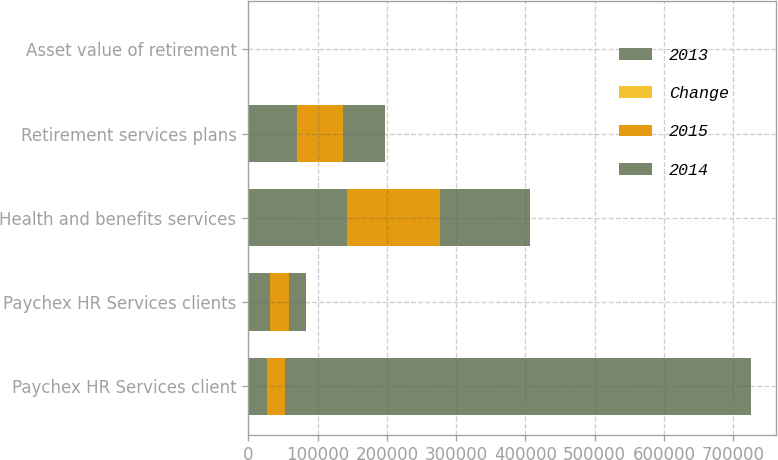Convert chart. <chart><loc_0><loc_0><loc_500><loc_500><stacked_bar_chart><ecel><fcel>Paychex HR Services client<fcel>Paychex HR Services clients<fcel>Health and benefits services<fcel>Retirement services plans<fcel>Asset value of retirement<nl><fcel>2013<fcel>26500<fcel>31000<fcel>142000<fcel>70000<fcel>23.5<nl><fcel>Change<fcel>12<fcel>11<fcel>6<fcel>6<fcel>7<nl><fcel>2015<fcel>26500<fcel>28000<fcel>134000<fcel>66000<fcel>21.9<nl><fcel>2014<fcel>672000<fcel>25000<fcel>131000<fcel>62000<fcel>19.3<nl></chart> 